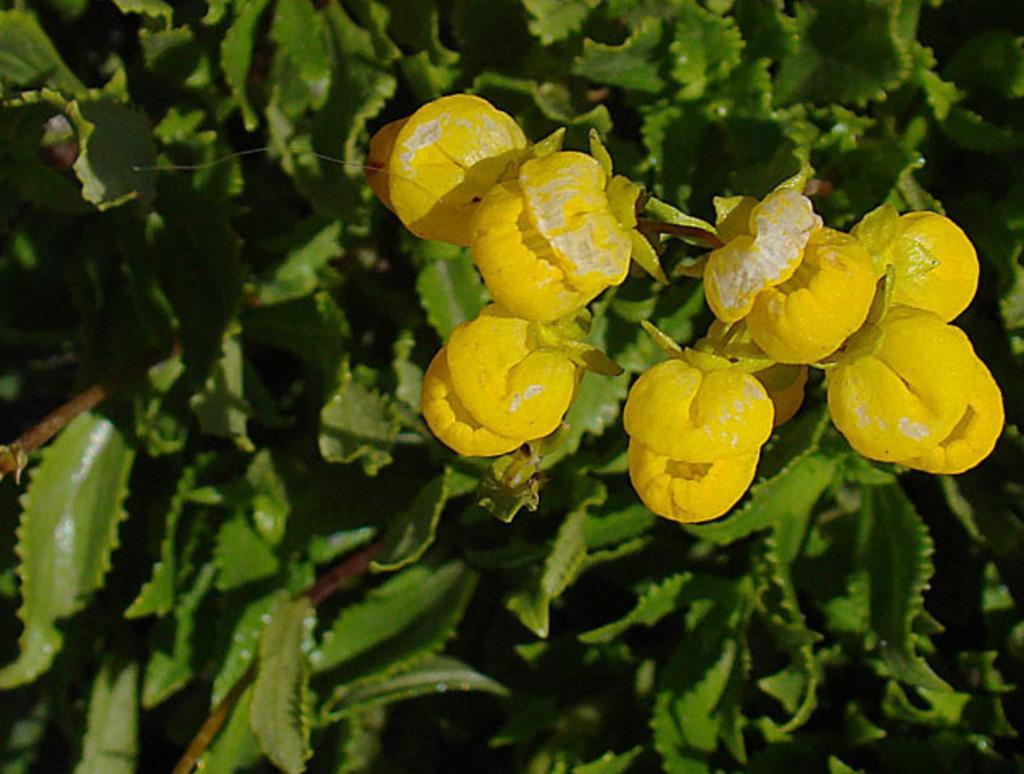What color are the flowers in the image? The flowers in the image are yellow. What other part of the plant can be seen in the image besides the flowers? There are green leaves in the image. What type of rifle is being held by the head in the box in the image? There is no rifle, head, or box present in the image; it only features yellow flowers and green leaves. 